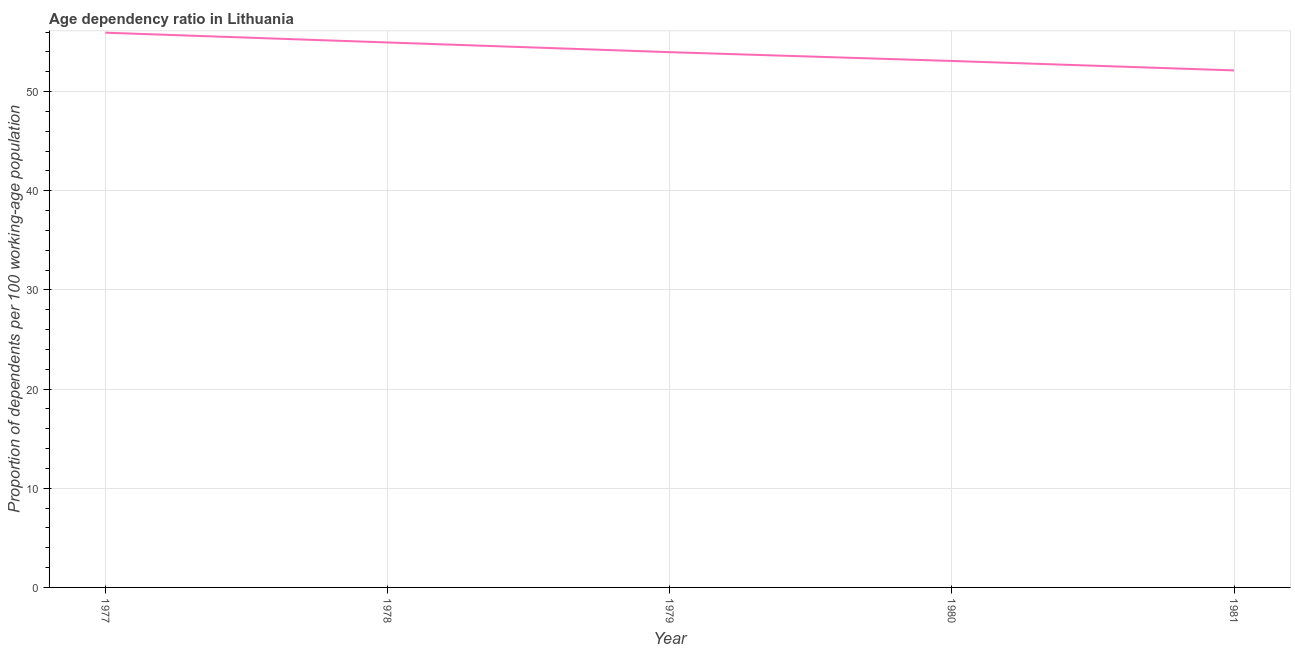What is the age dependency ratio in 1979?
Ensure brevity in your answer.  53.97. Across all years, what is the maximum age dependency ratio?
Ensure brevity in your answer.  55.93. Across all years, what is the minimum age dependency ratio?
Provide a short and direct response. 52.13. In which year was the age dependency ratio maximum?
Your answer should be compact. 1977. What is the sum of the age dependency ratio?
Ensure brevity in your answer.  270.06. What is the difference between the age dependency ratio in 1977 and 1978?
Your answer should be very brief. 0.98. What is the average age dependency ratio per year?
Make the answer very short. 54.01. What is the median age dependency ratio?
Offer a terse response. 53.97. What is the ratio of the age dependency ratio in 1978 to that in 1981?
Your answer should be very brief. 1.05. Is the difference between the age dependency ratio in 1978 and 1980 greater than the difference between any two years?
Your response must be concise. No. What is the difference between the highest and the second highest age dependency ratio?
Offer a terse response. 0.98. What is the difference between the highest and the lowest age dependency ratio?
Keep it short and to the point. 3.8. How many lines are there?
Keep it short and to the point. 1. What is the difference between two consecutive major ticks on the Y-axis?
Make the answer very short. 10. Are the values on the major ticks of Y-axis written in scientific E-notation?
Your answer should be very brief. No. Does the graph contain grids?
Make the answer very short. Yes. What is the title of the graph?
Provide a short and direct response. Age dependency ratio in Lithuania. What is the label or title of the X-axis?
Provide a short and direct response. Year. What is the label or title of the Y-axis?
Your answer should be compact. Proportion of dependents per 100 working-age population. What is the Proportion of dependents per 100 working-age population in 1977?
Your response must be concise. 55.93. What is the Proportion of dependents per 100 working-age population of 1978?
Keep it short and to the point. 54.95. What is the Proportion of dependents per 100 working-age population of 1979?
Ensure brevity in your answer.  53.97. What is the Proportion of dependents per 100 working-age population in 1980?
Provide a succinct answer. 53.08. What is the Proportion of dependents per 100 working-age population of 1981?
Give a very brief answer. 52.13. What is the difference between the Proportion of dependents per 100 working-age population in 1977 and 1978?
Give a very brief answer. 0.98. What is the difference between the Proportion of dependents per 100 working-age population in 1977 and 1979?
Provide a short and direct response. 1.96. What is the difference between the Proportion of dependents per 100 working-age population in 1977 and 1980?
Keep it short and to the point. 2.85. What is the difference between the Proportion of dependents per 100 working-age population in 1977 and 1981?
Your answer should be very brief. 3.8. What is the difference between the Proportion of dependents per 100 working-age population in 1978 and 1979?
Provide a succinct answer. 0.98. What is the difference between the Proportion of dependents per 100 working-age population in 1978 and 1980?
Make the answer very short. 1.87. What is the difference between the Proportion of dependents per 100 working-age population in 1978 and 1981?
Give a very brief answer. 2.82. What is the difference between the Proportion of dependents per 100 working-age population in 1979 and 1980?
Ensure brevity in your answer.  0.89. What is the difference between the Proportion of dependents per 100 working-age population in 1979 and 1981?
Offer a terse response. 1.84. What is the difference between the Proportion of dependents per 100 working-age population in 1980 and 1981?
Your answer should be very brief. 0.95. What is the ratio of the Proportion of dependents per 100 working-age population in 1977 to that in 1979?
Ensure brevity in your answer.  1.04. What is the ratio of the Proportion of dependents per 100 working-age population in 1977 to that in 1980?
Keep it short and to the point. 1.05. What is the ratio of the Proportion of dependents per 100 working-age population in 1977 to that in 1981?
Offer a terse response. 1.07. What is the ratio of the Proportion of dependents per 100 working-age population in 1978 to that in 1979?
Your response must be concise. 1.02. What is the ratio of the Proportion of dependents per 100 working-age population in 1978 to that in 1980?
Keep it short and to the point. 1.03. What is the ratio of the Proportion of dependents per 100 working-age population in 1978 to that in 1981?
Ensure brevity in your answer.  1.05. What is the ratio of the Proportion of dependents per 100 working-age population in 1979 to that in 1980?
Provide a short and direct response. 1.02. What is the ratio of the Proportion of dependents per 100 working-age population in 1979 to that in 1981?
Provide a short and direct response. 1.03. 